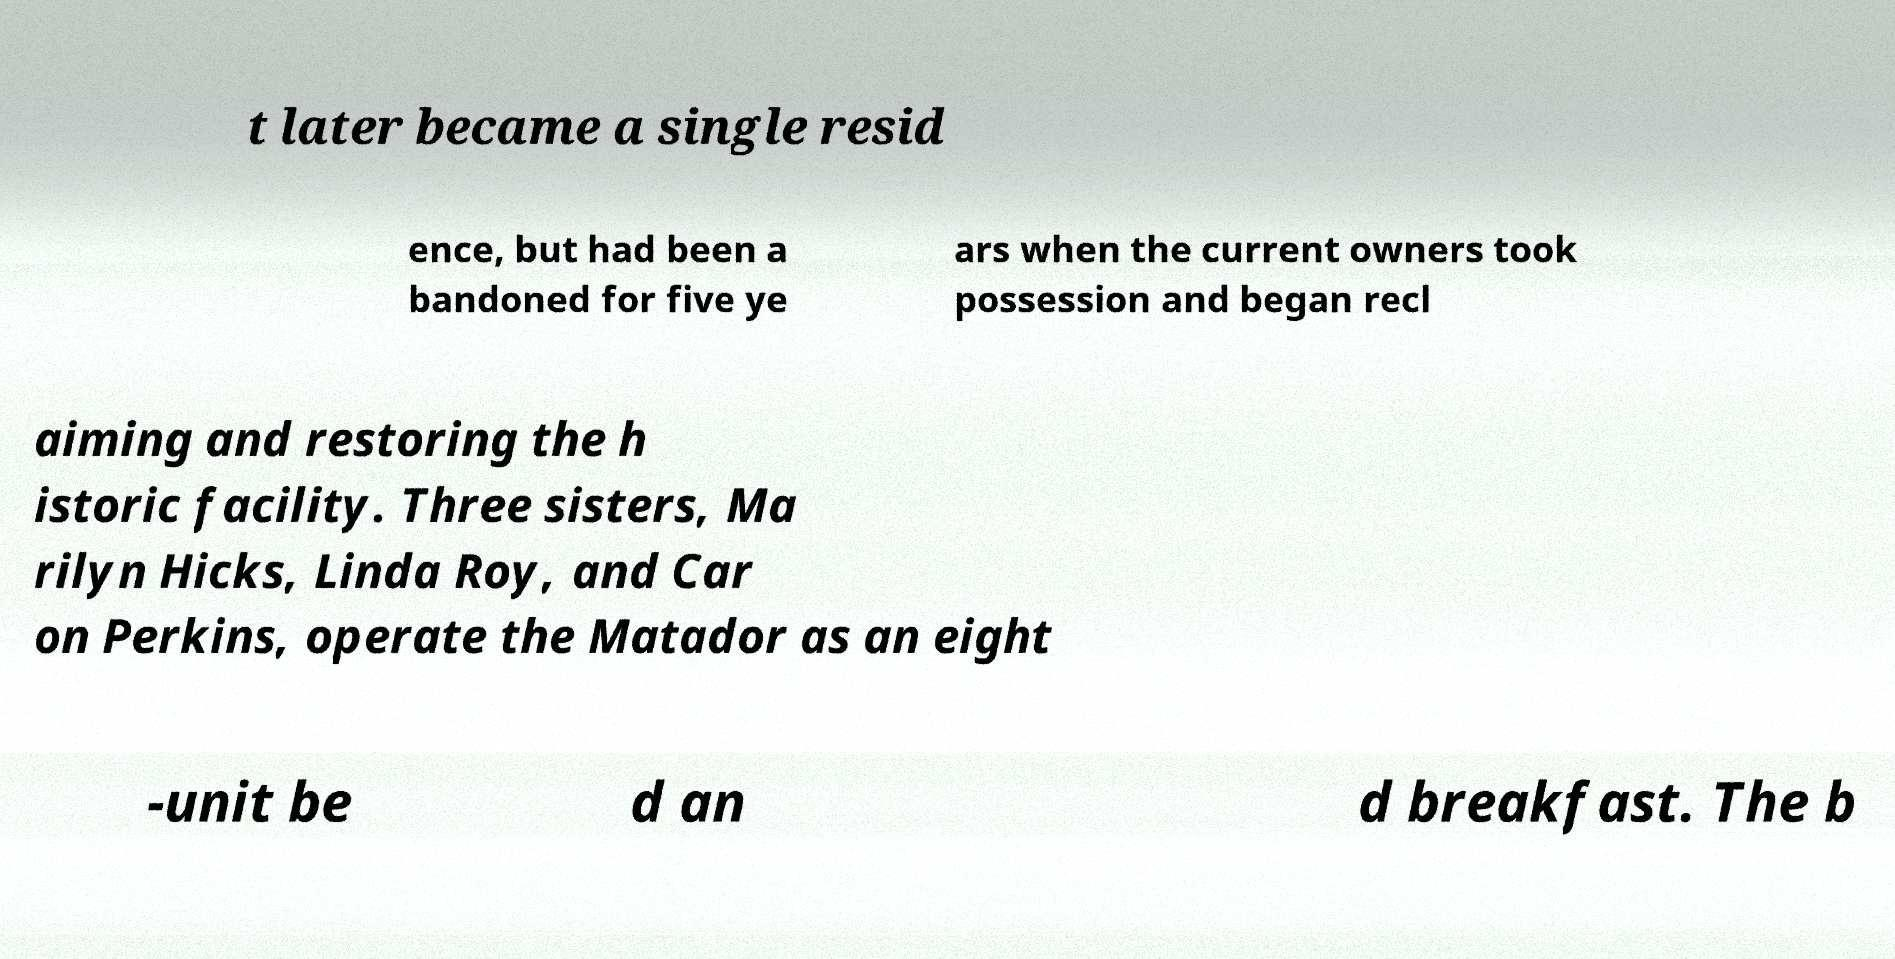Could you assist in decoding the text presented in this image and type it out clearly? t later became a single resid ence, but had been a bandoned for five ye ars when the current owners took possession and began recl aiming and restoring the h istoric facility. Three sisters, Ma rilyn Hicks, Linda Roy, and Car on Perkins, operate the Matador as an eight -unit be d an d breakfast. The b 